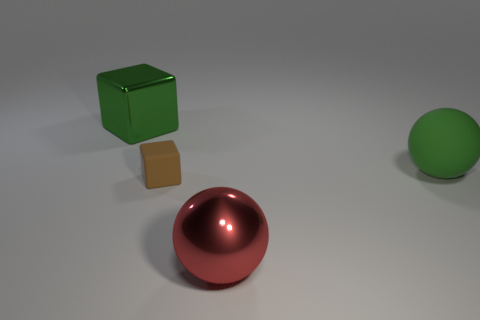Are any red objects visible?
Offer a very short reply. Yes. There is a green object on the right side of the red metal ball; does it have the same size as the shiny object right of the brown block?
Offer a terse response. Yes. There is a object that is both behind the brown rubber thing and right of the tiny cube; what material is it made of?
Provide a short and direct response. Rubber. There is a tiny brown rubber block; what number of red spheres are left of it?
Your answer should be very brief. 0. Is there any other thing that is the same size as the green metallic thing?
Make the answer very short. Yes. What is the color of the other thing that is the same material as the red object?
Offer a very short reply. Green. Is the large green metal object the same shape as the green matte thing?
Your response must be concise. No. What number of big green things are both to the left of the small brown block and right of the big green cube?
Provide a short and direct response. 0. How many metal objects are either small objects or yellow balls?
Keep it short and to the point. 0. There is a ball left of the large ball that is behind the brown matte cube; what size is it?
Make the answer very short. Large. 